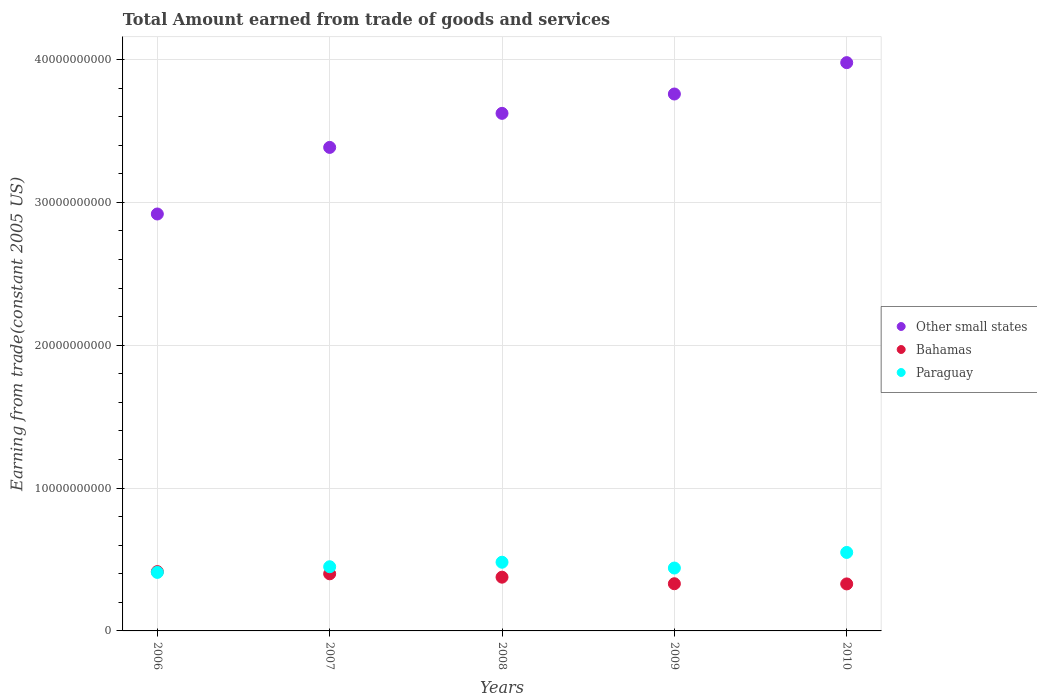How many different coloured dotlines are there?
Ensure brevity in your answer.  3. Is the number of dotlines equal to the number of legend labels?
Give a very brief answer. Yes. What is the total amount earned by trading goods and services in Bahamas in 2009?
Your answer should be very brief. 3.30e+09. Across all years, what is the maximum total amount earned by trading goods and services in Bahamas?
Provide a short and direct response. 4.15e+09. Across all years, what is the minimum total amount earned by trading goods and services in Other small states?
Offer a very short reply. 2.92e+1. What is the total total amount earned by trading goods and services in Paraguay in the graph?
Ensure brevity in your answer.  2.33e+1. What is the difference between the total amount earned by trading goods and services in Bahamas in 2006 and that in 2008?
Give a very brief answer. 3.89e+08. What is the difference between the total amount earned by trading goods and services in Other small states in 2010 and the total amount earned by trading goods and services in Bahamas in 2007?
Ensure brevity in your answer.  3.58e+1. What is the average total amount earned by trading goods and services in Bahamas per year?
Give a very brief answer. 3.70e+09. In the year 2009, what is the difference between the total amount earned by trading goods and services in Other small states and total amount earned by trading goods and services in Bahamas?
Provide a succinct answer. 3.43e+1. In how many years, is the total amount earned by trading goods and services in Bahamas greater than 16000000000 US$?
Ensure brevity in your answer.  0. What is the ratio of the total amount earned by trading goods and services in Paraguay in 2008 to that in 2010?
Give a very brief answer. 0.88. Is the difference between the total amount earned by trading goods and services in Other small states in 2006 and 2007 greater than the difference between the total amount earned by trading goods and services in Bahamas in 2006 and 2007?
Your answer should be compact. No. What is the difference between the highest and the second highest total amount earned by trading goods and services in Bahamas?
Your response must be concise. 1.53e+08. What is the difference between the highest and the lowest total amount earned by trading goods and services in Paraguay?
Your answer should be very brief. 1.40e+09. In how many years, is the total amount earned by trading goods and services in Other small states greater than the average total amount earned by trading goods and services in Other small states taken over all years?
Offer a terse response. 3. Is the sum of the total amount earned by trading goods and services in Paraguay in 2006 and 2008 greater than the maximum total amount earned by trading goods and services in Bahamas across all years?
Offer a very short reply. Yes. Is it the case that in every year, the sum of the total amount earned by trading goods and services in Bahamas and total amount earned by trading goods and services in Other small states  is greater than the total amount earned by trading goods and services in Paraguay?
Your response must be concise. Yes. Does the total amount earned by trading goods and services in Other small states monotonically increase over the years?
Give a very brief answer. Yes. Is the total amount earned by trading goods and services in Paraguay strictly greater than the total amount earned by trading goods and services in Bahamas over the years?
Provide a short and direct response. No. Is the total amount earned by trading goods and services in Bahamas strictly less than the total amount earned by trading goods and services in Paraguay over the years?
Provide a short and direct response. No. How many dotlines are there?
Your answer should be compact. 3. Does the graph contain any zero values?
Provide a succinct answer. No. Does the graph contain grids?
Your response must be concise. Yes. Where does the legend appear in the graph?
Make the answer very short. Center right. How many legend labels are there?
Provide a short and direct response. 3. What is the title of the graph?
Your answer should be very brief. Total Amount earned from trade of goods and services. Does "Bosnia and Herzegovina" appear as one of the legend labels in the graph?
Give a very brief answer. No. What is the label or title of the Y-axis?
Offer a terse response. Earning from trade(constant 2005 US). What is the Earning from trade(constant 2005 US) of Other small states in 2006?
Provide a succinct answer. 2.92e+1. What is the Earning from trade(constant 2005 US) in Bahamas in 2006?
Your answer should be very brief. 4.15e+09. What is the Earning from trade(constant 2005 US) of Paraguay in 2006?
Provide a short and direct response. 4.10e+09. What is the Earning from trade(constant 2005 US) of Other small states in 2007?
Provide a short and direct response. 3.39e+1. What is the Earning from trade(constant 2005 US) of Bahamas in 2007?
Your answer should be very brief. 4.00e+09. What is the Earning from trade(constant 2005 US) in Paraguay in 2007?
Give a very brief answer. 4.49e+09. What is the Earning from trade(constant 2005 US) of Other small states in 2008?
Your answer should be very brief. 3.62e+1. What is the Earning from trade(constant 2005 US) in Bahamas in 2008?
Ensure brevity in your answer.  3.76e+09. What is the Earning from trade(constant 2005 US) of Paraguay in 2008?
Give a very brief answer. 4.81e+09. What is the Earning from trade(constant 2005 US) of Other small states in 2009?
Provide a short and direct response. 3.76e+1. What is the Earning from trade(constant 2005 US) in Bahamas in 2009?
Provide a short and direct response. 3.30e+09. What is the Earning from trade(constant 2005 US) in Paraguay in 2009?
Provide a succinct answer. 4.40e+09. What is the Earning from trade(constant 2005 US) of Other small states in 2010?
Give a very brief answer. 3.98e+1. What is the Earning from trade(constant 2005 US) in Bahamas in 2010?
Make the answer very short. 3.29e+09. What is the Earning from trade(constant 2005 US) of Paraguay in 2010?
Your answer should be compact. 5.49e+09. Across all years, what is the maximum Earning from trade(constant 2005 US) of Other small states?
Your answer should be compact. 3.98e+1. Across all years, what is the maximum Earning from trade(constant 2005 US) of Bahamas?
Provide a short and direct response. 4.15e+09. Across all years, what is the maximum Earning from trade(constant 2005 US) of Paraguay?
Provide a short and direct response. 5.49e+09. Across all years, what is the minimum Earning from trade(constant 2005 US) in Other small states?
Your answer should be compact. 2.92e+1. Across all years, what is the minimum Earning from trade(constant 2005 US) of Bahamas?
Your response must be concise. 3.29e+09. Across all years, what is the minimum Earning from trade(constant 2005 US) of Paraguay?
Ensure brevity in your answer.  4.10e+09. What is the total Earning from trade(constant 2005 US) of Other small states in the graph?
Give a very brief answer. 1.77e+11. What is the total Earning from trade(constant 2005 US) of Bahamas in the graph?
Offer a very short reply. 1.85e+1. What is the total Earning from trade(constant 2005 US) of Paraguay in the graph?
Make the answer very short. 2.33e+1. What is the difference between the Earning from trade(constant 2005 US) of Other small states in 2006 and that in 2007?
Your response must be concise. -4.66e+09. What is the difference between the Earning from trade(constant 2005 US) in Bahamas in 2006 and that in 2007?
Offer a very short reply. 1.53e+08. What is the difference between the Earning from trade(constant 2005 US) in Paraguay in 2006 and that in 2007?
Offer a very short reply. -3.97e+08. What is the difference between the Earning from trade(constant 2005 US) in Other small states in 2006 and that in 2008?
Make the answer very short. -7.05e+09. What is the difference between the Earning from trade(constant 2005 US) in Bahamas in 2006 and that in 2008?
Your answer should be very brief. 3.89e+08. What is the difference between the Earning from trade(constant 2005 US) of Paraguay in 2006 and that in 2008?
Your answer should be compact. -7.13e+08. What is the difference between the Earning from trade(constant 2005 US) of Other small states in 2006 and that in 2009?
Offer a very short reply. -8.40e+09. What is the difference between the Earning from trade(constant 2005 US) in Bahamas in 2006 and that in 2009?
Give a very brief answer. 8.48e+08. What is the difference between the Earning from trade(constant 2005 US) of Paraguay in 2006 and that in 2009?
Offer a very short reply. -3.06e+08. What is the difference between the Earning from trade(constant 2005 US) of Other small states in 2006 and that in 2010?
Offer a terse response. -1.06e+1. What is the difference between the Earning from trade(constant 2005 US) of Bahamas in 2006 and that in 2010?
Provide a succinct answer. 8.61e+08. What is the difference between the Earning from trade(constant 2005 US) in Paraguay in 2006 and that in 2010?
Keep it short and to the point. -1.40e+09. What is the difference between the Earning from trade(constant 2005 US) of Other small states in 2007 and that in 2008?
Your answer should be very brief. -2.38e+09. What is the difference between the Earning from trade(constant 2005 US) in Bahamas in 2007 and that in 2008?
Your answer should be very brief. 2.36e+08. What is the difference between the Earning from trade(constant 2005 US) in Paraguay in 2007 and that in 2008?
Offer a terse response. -3.17e+08. What is the difference between the Earning from trade(constant 2005 US) in Other small states in 2007 and that in 2009?
Offer a very short reply. -3.74e+09. What is the difference between the Earning from trade(constant 2005 US) of Bahamas in 2007 and that in 2009?
Give a very brief answer. 6.95e+08. What is the difference between the Earning from trade(constant 2005 US) in Paraguay in 2007 and that in 2009?
Keep it short and to the point. 9.03e+07. What is the difference between the Earning from trade(constant 2005 US) of Other small states in 2007 and that in 2010?
Keep it short and to the point. -5.93e+09. What is the difference between the Earning from trade(constant 2005 US) in Bahamas in 2007 and that in 2010?
Give a very brief answer. 7.08e+08. What is the difference between the Earning from trade(constant 2005 US) of Paraguay in 2007 and that in 2010?
Your response must be concise. -1.00e+09. What is the difference between the Earning from trade(constant 2005 US) of Other small states in 2008 and that in 2009?
Ensure brevity in your answer.  -1.35e+09. What is the difference between the Earning from trade(constant 2005 US) of Bahamas in 2008 and that in 2009?
Provide a succinct answer. 4.59e+08. What is the difference between the Earning from trade(constant 2005 US) of Paraguay in 2008 and that in 2009?
Offer a terse response. 4.07e+08. What is the difference between the Earning from trade(constant 2005 US) of Other small states in 2008 and that in 2010?
Offer a terse response. -3.55e+09. What is the difference between the Earning from trade(constant 2005 US) in Bahamas in 2008 and that in 2010?
Provide a short and direct response. 4.72e+08. What is the difference between the Earning from trade(constant 2005 US) in Paraguay in 2008 and that in 2010?
Ensure brevity in your answer.  -6.85e+08. What is the difference between the Earning from trade(constant 2005 US) of Other small states in 2009 and that in 2010?
Offer a terse response. -2.20e+09. What is the difference between the Earning from trade(constant 2005 US) in Bahamas in 2009 and that in 2010?
Ensure brevity in your answer.  1.29e+07. What is the difference between the Earning from trade(constant 2005 US) in Paraguay in 2009 and that in 2010?
Provide a succinct answer. -1.09e+09. What is the difference between the Earning from trade(constant 2005 US) of Other small states in 2006 and the Earning from trade(constant 2005 US) of Bahamas in 2007?
Give a very brief answer. 2.52e+1. What is the difference between the Earning from trade(constant 2005 US) in Other small states in 2006 and the Earning from trade(constant 2005 US) in Paraguay in 2007?
Provide a short and direct response. 2.47e+1. What is the difference between the Earning from trade(constant 2005 US) of Bahamas in 2006 and the Earning from trade(constant 2005 US) of Paraguay in 2007?
Your response must be concise. -3.41e+08. What is the difference between the Earning from trade(constant 2005 US) of Other small states in 2006 and the Earning from trade(constant 2005 US) of Bahamas in 2008?
Your answer should be compact. 2.54e+1. What is the difference between the Earning from trade(constant 2005 US) of Other small states in 2006 and the Earning from trade(constant 2005 US) of Paraguay in 2008?
Your response must be concise. 2.44e+1. What is the difference between the Earning from trade(constant 2005 US) in Bahamas in 2006 and the Earning from trade(constant 2005 US) in Paraguay in 2008?
Your answer should be very brief. -6.58e+08. What is the difference between the Earning from trade(constant 2005 US) in Other small states in 2006 and the Earning from trade(constant 2005 US) in Bahamas in 2009?
Make the answer very short. 2.59e+1. What is the difference between the Earning from trade(constant 2005 US) in Other small states in 2006 and the Earning from trade(constant 2005 US) in Paraguay in 2009?
Your answer should be very brief. 2.48e+1. What is the difference between the Earning from trade(constant 2005 US) of Bahamas in 2006 and the Earning from trade(constant 2005 US) of Paraguay in 2009?
Your response must be concise. -2.51e+08. What is the difference between the Earning from trade(constant 2005 US) of Other small states in 2006 and the Earning from trade(constant 2005 US) of Bahamas in 2010?
Ensure brevity in your answer.  2.59e+1. What is the difference between the Earning from trade(constant 2005 US) in Other small states in 2006 and the Earning from trade(constant 2005 US) in Paraguay in 2010?
Your response must be concise. 2.37e+1. What is the difference between the Earning from trade(constant 2005 US) of Bahamas in 2006 and the Earning from trade(constant 2005 US) of Paraguay in 2010?
Offer a very short reply. -1.34e+09. What is the difference between the Earning from trade(constant 2005 US) in Other small states in 2007 and the Earning from trade(constant 2005 US) in Bahamas in 2008?
Offer a very short reply. 3.01e+1. What is the difference between the Earning from trade(constant 2005 US) in Other small states in 2007 and the Earning from trade(constant 2005 US) in Paraguay in 2008?
Offer a very short reply. 2.90e+1. What is the difference between the Earning from trade(constant 2005 US) in Bahamas in 2007 and the Earning from trade(constant 2005 US) in Paraguay in 2008?
Your response must be concise. -8.11e+08. What is the difference between the Earning from trade(constant 2005 US) of Other small states in 2007 and the Earning from trade(constant 2005 US) of Bahamas in 2009?
Keep it short and to the point. 3.05e+1. What is the difference between the Earning from trade(constant 2005 US) of Other small states in 2007 and the Earning from trade(constant 2005 US) of Paraguay in 2009?
Give a very brief answer. 2.94e+1. What is the difference between the Earning from trade(constant 2005 US) in Bahamas in 2007 and the Earning from trade(constant 2005 US) in Paraguay in 2009?
Offer a terse response. -4.04e+08. What is the difference between the Earning from trade(constant 2005 US) of Other small states in 2007 and the Earning from trade(constant 2005 US) of Bahamas in 2010?
Offer a terse response. 3.06e+1. What is the difference between the Earning from trade(constant 2005 US) of Other small states in 2007 and the Earning from trade(constant 2005 US) of Paraguay in 2010?
Offer a terse response. 2.84e+1. What is the difference between the Earning from trade(constant 2005 US) of Bahamas in 2007 and the Earning from trade(constant 2005 US) of Paraguay in 2010?
Make the answer very short. -1.50e+09. What is the difference between the Earning from trade(constant 2005 US) of Other small states in 2008 and the Earning from trade(constant 2005 US) of Bahamas in 2009?
Your response must be concise. 3.29e+1. What is the difference between the Earning from trade(constant 2005 US) in Other small states in 2008 and the Earning from trade(constant 2005 US) in Paraguay in 2009?
Your answer should be compact. 3.18e+1. What is the difference between the Earning from trade(constant 2005 US) of Bahamas in 2008 and the Earning from trade(constant 2005 US) of Paraguay in 2009?
Provide a succinct answer. -6.40e+08. What is the difference between the Earning from trade(constant 2005 US) in Other small states in 2008 and the Earning from trade(constant 2005 US) in Bahamas in 2010?
Keep it short and to the point. 3.29e+1. What is the difference between the Earning from trade(constant 2005 US) of Other small states in 2008 and the Earning from trade(constant 2005 US) of Paraguay in 2010?
Provide a succinct answer. 3.07e+1. What is the difference between the Earning from trade(constant 2005 US) of Bahamas in 2008 and the Earning from trade(constant 2005 US) of Paraguay in 2010?
Your answer should be compact. -1.73e+09. What is the difference between the Earning from trade(constant 2005 US) of Other small states in 2009 and the Earning from trade(constant 2005 US) of Bahamas in 2010?
Your response must be concise. 3.43e+1. What is the difference between the Earning from trade(constant 2005 US) of Other small states in 2009 and the Earning from trade(constant 2005 US) of Paraguay in 2010?
Give a very brief answer. 3.21e+1. What is the difference between the Earning from trade(constant 2005 US) of Bahamas in 2009 and the Earning from trade(constant 2005 US) of Paraguay in 2010?
Offer a terse response. -2.19e+09. What is the average Earning from trade(constant 2005 US) of Other small states per year?
Offer a terse response. 3.53e+1. What is the average Earning from trade(constant 2005 US) of Bahamas per year?
Give a very brief answer. 3.70e+09. What is the average Earning from trade(constant 2005 US) of Paraguay per year?
Offer a terse response. 4.66e+09. In the year 2006, what is the difference between the Earning from trade(constant 2005 US) of Other small states and Earning from trade(constant 2005 US) of Bahamas?
Provide a short and direct response. 2.50e+1. In the year 2006, what is the difference between the Earning from trade(constant 2005 US) of Other small states and Earning from trade(constant 2005 US) of Paraguay?
Offer a very short reply. 2.51e+1. In the year 2006, what is the difference between the Earning from trade(constant 2005 US) in Bahamas and Earning from trade(constant 2005 US) in Paraguay?
Offer a very short reply. 5.54e+07. In the year 2007, what is the difference between the Earning from trade(constant 2005 US) of Other small states and Earning from trade(constant 2005 US) of Bahamas?
Offer a terse response. 2.99e+1. In the year 2007, what is the difference between the Earning from trade(constant 2005 US) of Other small states and Earning from trade(constant 2005 US) of Paraguay?
Offer a very short reply. 2.94e+1. In the year 2007, what is the difference between the Earning from trade(constant 2005 US) of Bahamas and Earning from trade(constant 2005 US) of Paraguay?
Your answer should be compact. -4.94e+08. In the year 2008, what is the difference between the Earning from trade(constant 2005 US) in Other small states and Earning from trade(constant 2005 US) in Bahamas?
Make the answer very short. 3.25e+1. In the year 2008, what is the difference between the Earning from trade(constant 2005 US) in Other small states and Earning from trade(constant 2005 US) in Paraguay?
Your answer should be compact. 3.14e+1. In the year 2008, what is the difference between the Earning from trade(constant 2005 US) of Bahamas and Earning from trade(constant 2005 US) of Paraguay?
Your answer should be compact. -1.05e+09. In the year 2009, what is the difference between the Earning from trade(constant 2005 US) in Other small states and Earning from trade(constant 2005 US) in Bahamas?
Ensure brevity in your answer.  3.43e+1. In the year 2009, what is the difference between the Earning from trade(constant 2005 US) of Other small states and Earning from trade(constant 2005 US) of Paraguay?
Provide a short and direct response. 3.32e+1. In the year 2009, what is the difference between the Earning from trade(constant 2005 US) in Bahamas and Earning from trade(constant 2005 US) in Paraguay?
Your answer should be compact. -1.10e+09. In the year 2010, what is the difference between the Earning from trade(constant 2005 US) in Other small states and Earning from trade(constant 2005 US) in Bahamas?
Provide a short and direct response. 3.65e+1. In the year 2010, what is the difference between the Earning from trade(constant 2005 US) in Other small states and Earning from trade(constant 2005 US) in Paraguay?
Make the answer very short. 3.43e+1. In the year 2010, what is the difference between the Earning from trade(constant 2005 US) in Bahamas and Earning from trade(constant 2005 US) in Paraguay?
Ensure brevity in your answer.  -2.20e+09. What is the ratio of the Earning from trade(constant 2005 US) in Other small states in 2006 to that in 2007?
Provide a short and direct response. 0.86. What is the ratio of the Earning from trade(constant 2005 US) in Bahamas in 2006 to that in 2007?
Ensure brevity in your answer.  1.04. What is the ratio of the Earning from trade(constant 2005 US) of Paraguay in 2006 to that in 2007?
Make the answer very short. 0.91. What is the ratio of the Earning from trade(constant 2005 US) of Other small states in 2006 to that in 2008?
Offer a very short reply. 0.81. What is the ratio of the Earning from trade(constant 2005 US) in Bahamas in 2006 to that in 2008?
Offer a very short reply. 1.1. What is the ratio of the Earning from trade(constant 2005 US) in Paraguay in 2006 to that in 2008?
Your answer should be compact. 0.85. What is the ratio of the Earning from trade(constant 2005 US) in Other small states in 2006 to that in 2009?
Keep it short and to the point. 0.78. What is the ratio of the Earning from trade(constant 2005 US) in Bahamas in 2006 to that in 2009?
Your answer should be very brief. 1.26. What is the ratio of the Earning from trade(constant 2005 US) in Paraguay in 2006 to that in 2009?
Make the answer very short. 0.93. What is the ratio of the Earning from trade(constant 2005 US) of Other small states in 2006 to that in 2010?
Provide a succinct answer. 0.73. What is the ratio of the Earning from trade(constant 2005 US) of Bahamas in 2006 to that in 2010?
Make the answer very short. 1.26. What is the ratio of the Earning from trade(constant 2005 US) of Paraguay in 2006 to that in 2010?
Make the answer very short. 0.75. What is the ratio of the Earning from trade(constant 2005 US) of Other small states in 2007 to that in 2008?
Provide a short and direct response. 0.93. What is the ratio of the Earning from trade(constant 2005 US) of Bahamas in 2007 to that in 2008?
Provide a succinct answer. 1.06. What is the ratio of the Earning from trade(constant 2005 US) of Paraguay in 2007 to that in 2008?
Make the answer very short. 0.93. What is the ratio of the Earning from trade(constant 2005 US) of Other small states in 2007 to that in 2009?
Provide a succinct answer. 0.9. What is the ratio of the Earning from trade(constant 2005 US) in Bahamas in 2007 to that in 2009?
Provide a short and direct response. 1.21. What is the ratio of the Earning from trade(constant 2005 US) of Paraguay in 2007 to that in 2009?
Your answer should be compact. 1.02. What is the ratio of the Earning from trade(constant 2005 US) in Other small states in 2007 to that in 2010?
Give a very brief answer. 0.85. What is the ratio of the Earning from trade(constant 2005 US) of Bahamas in 2007 to that in 2010?
Offer a terse response. 1.22. What is the ratio of the Earning from trade(constant 2005 US) in Paraguay in 2007 to that in 2010?
Make the answer very short. 0.82. What is the ratio of the Earning from trade(constant 2005 US) in Other small states in 2008 to that in 2009?
Keep it short and to the point. 0.96. What is the ratio of the Earning from trade(constant 2005 US) in Bahamas in 2008 to that in 2009?
Provide a succinct answer. 1.14. What is the ratio of the Earning from trade(constant 2005 US) of Paraguay in 2008 to that in 2009?
Make the answer very short. 1.09. What is the ratio of the Earning from trade(constant 2005 US) of Other small states in 2008 to that in 2010?
Keep it short and to the point. 0.91. What is the ratio of the Earning from trade(constant 2005 US) in Bahamas in 2008 to that in 2010?
Offer a very short reply. 1.14. What is the ratio of the Earning from trade(constant 2005 US) of Paraguay in 2008 to that in 2010?
Ensure brevity in your answer.  0.88. What is the ratio of the Earning from trade(constant 2005 US) of Other small states in 2009 to that in 2010?
Keep it short and to the point. 0.94. What is the ratio of the Earning from trade(constant 2005 US) in Paraguay in 2009 to that in 2010?
Offer a terse response. 0.8. What is the difference between the highest and the second highest Earning from trade(constant 2005 US) in Other small states?
Provide a short and direct response. 2.20e+09. What is the difference between the highest and the second highest Earning from trade(constant 2005 US) in Bahamas?
Your response must be concise. 1.53e+08. What is the difference between the highest and the second highest Earning from trade(constant 2005 US) in Paraguay?
Ensure brevity in your answer.  6.85e+08. What is the difference between the highest and the lowest Earning from trade(constant 2005 US) of Other small states?
Your answer should be very brief. 1.06e+1. What is the difference between the highest and the lowest Earning from trade(constant 2005 US) in Bahamas?
Ensure brevity in your answer.  8.61e+08. What is the difference between the highest and the lowest Earning from trade(constant 2005 US) of Paraguay?
Provide a short and direct response. 1.40e+09. 